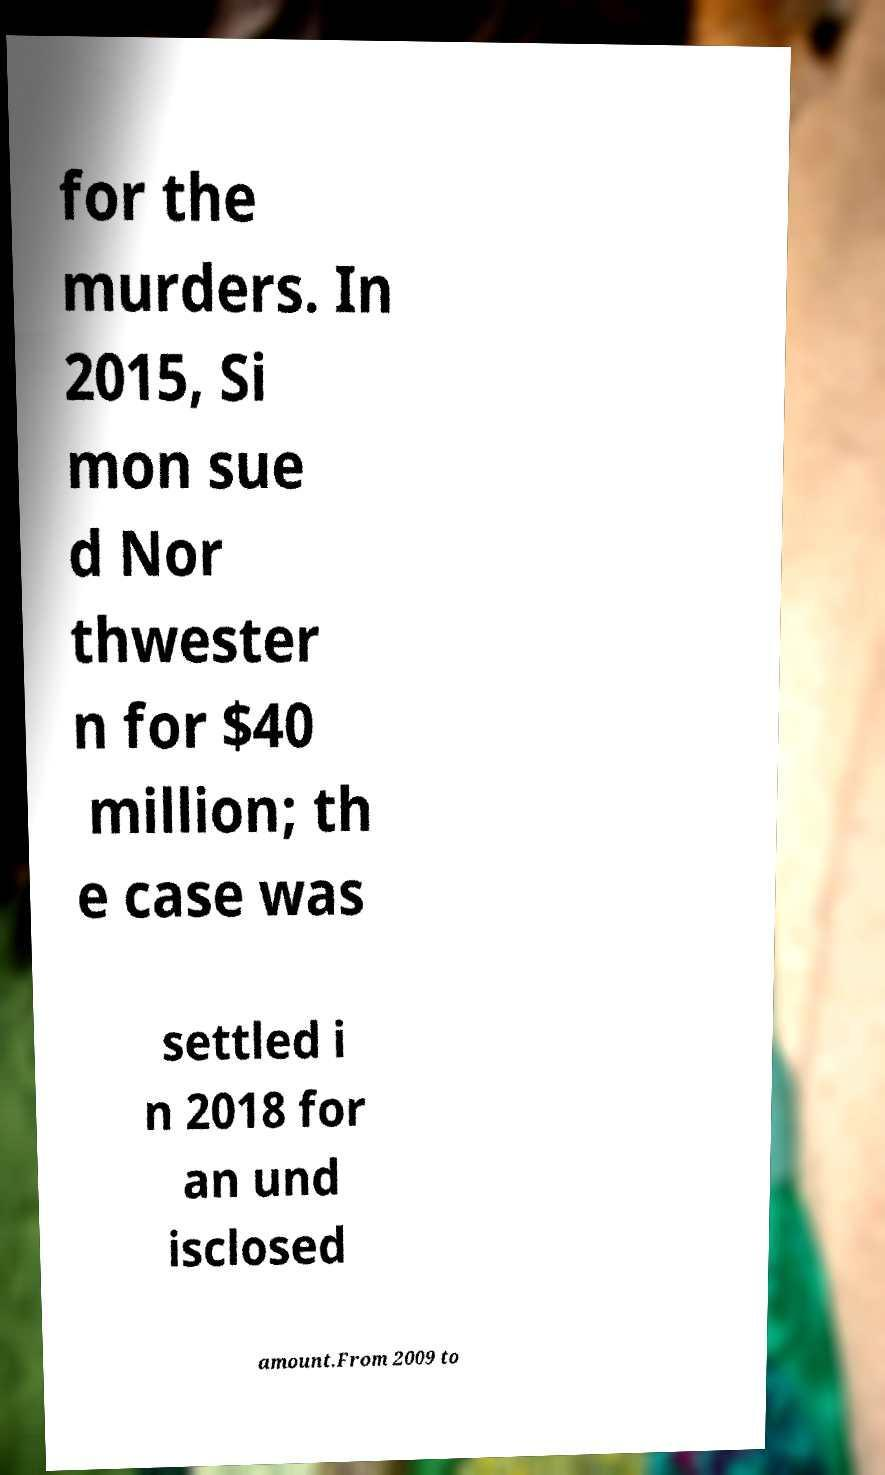There's text embedded in this image that I need extracted. Can you transcribe it verbatim? for the murders. In 2015, Si mon sue d Nor thwester n for $40 million; th e case was settled i n 2018 for an und isclosed amount.From 2009 to 